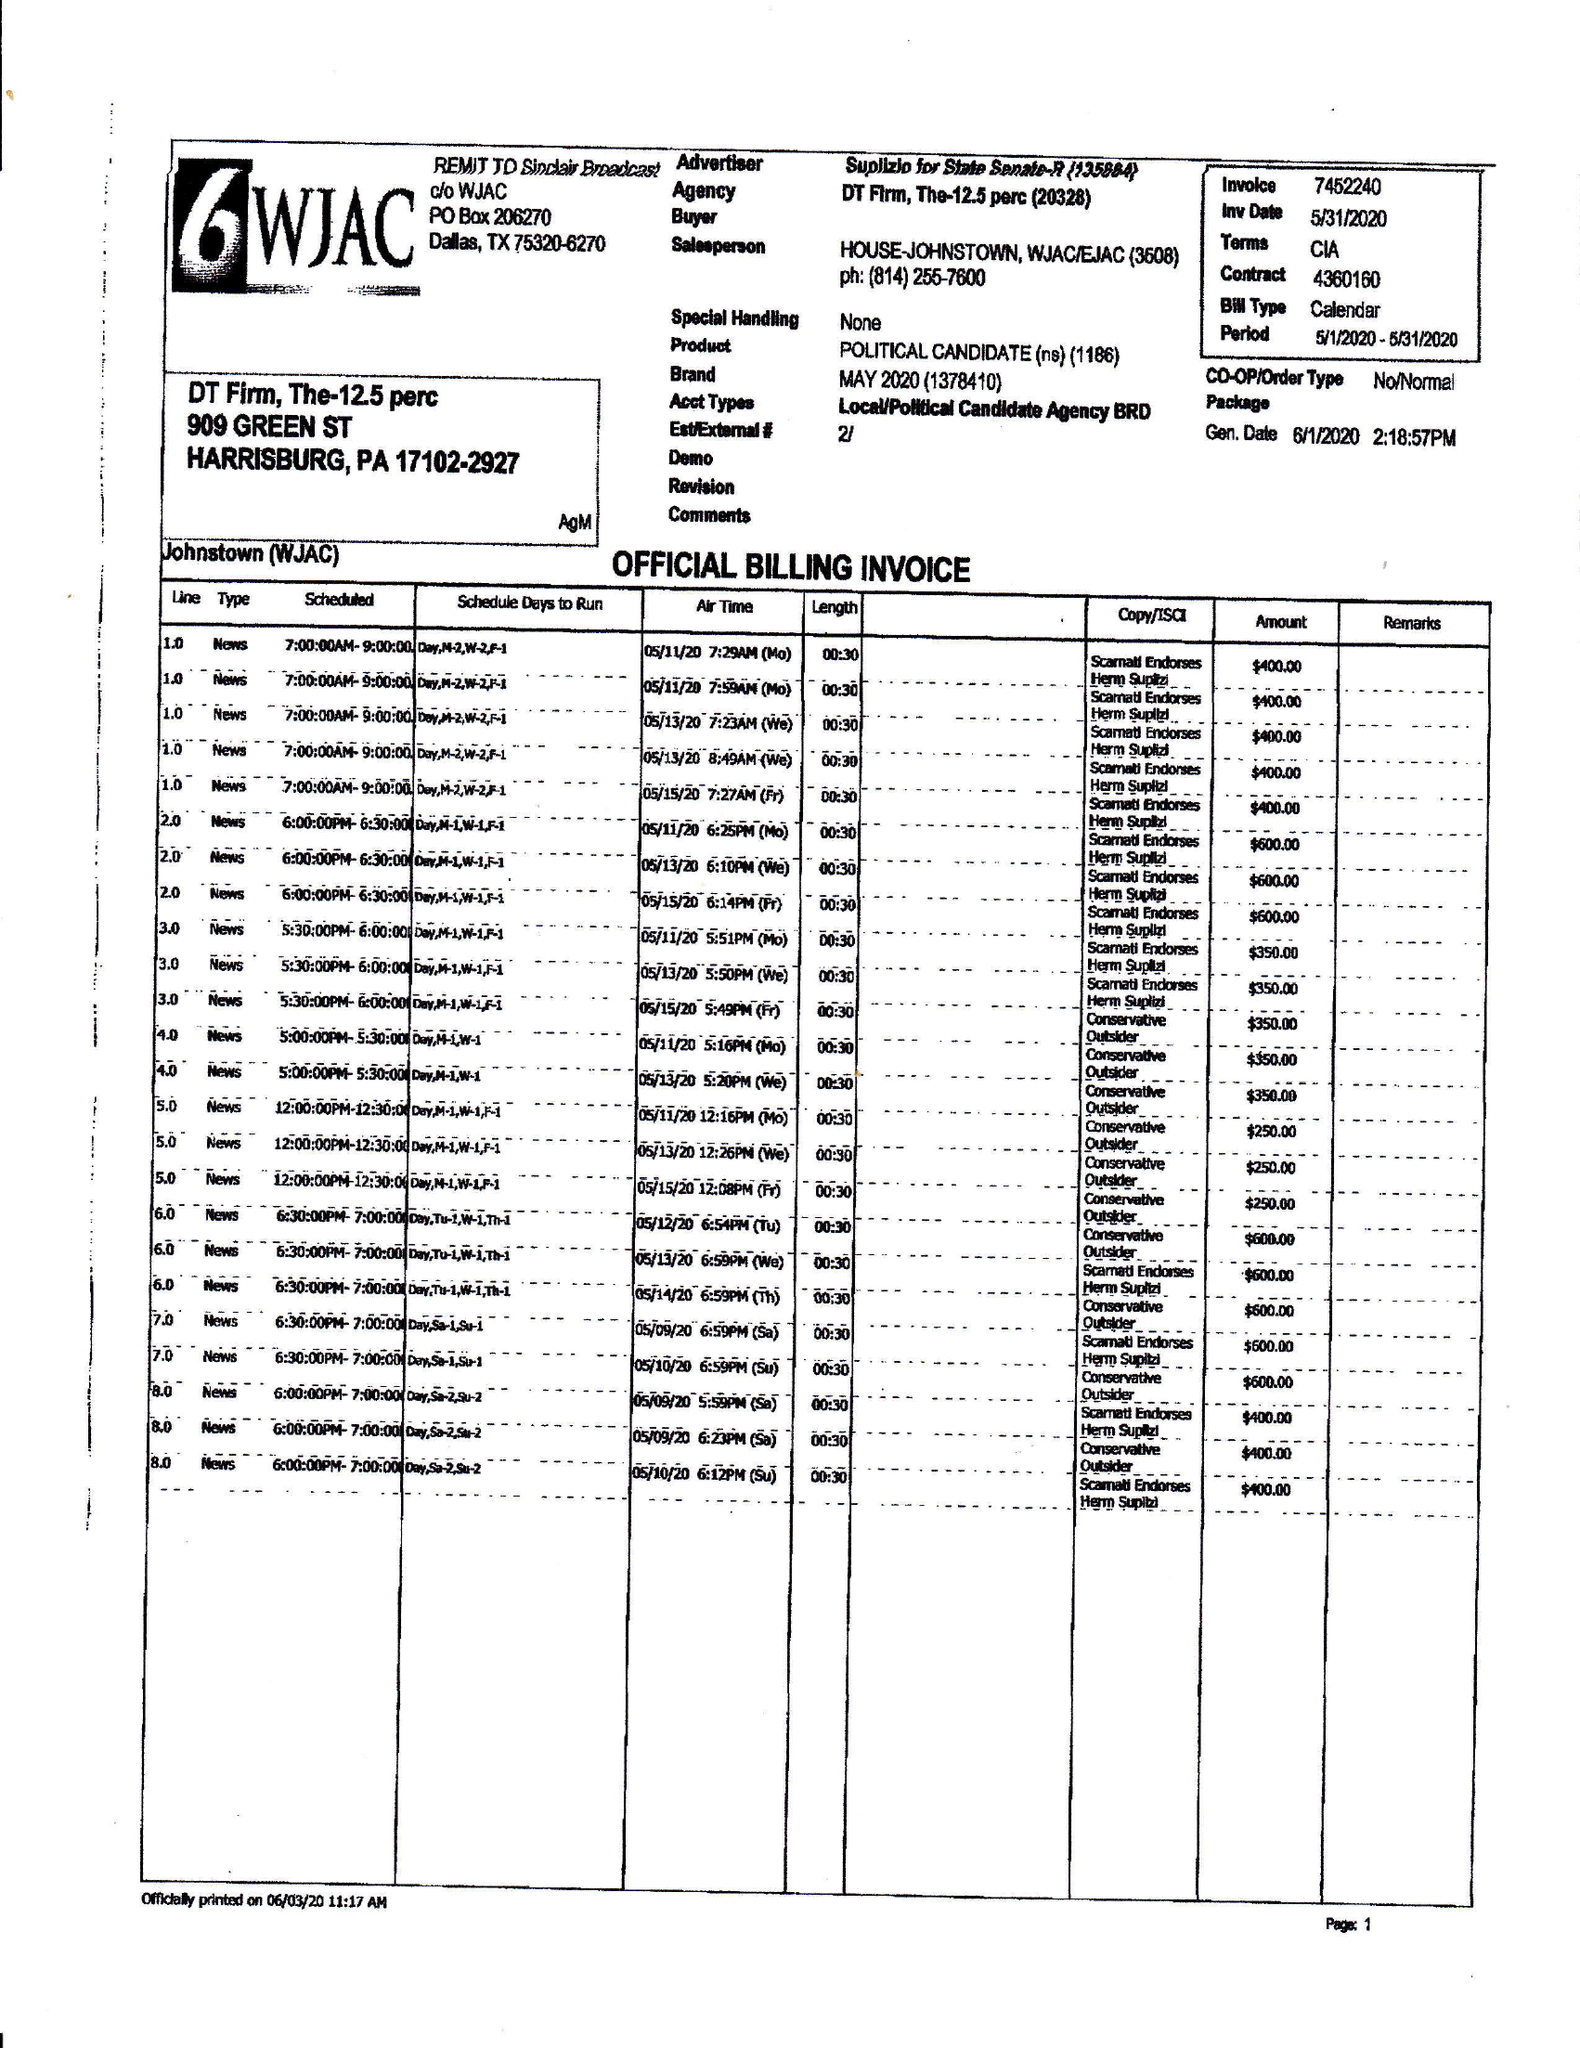What is the value for the contract_num?
Answer the question using a single word or phrase. 4360160 